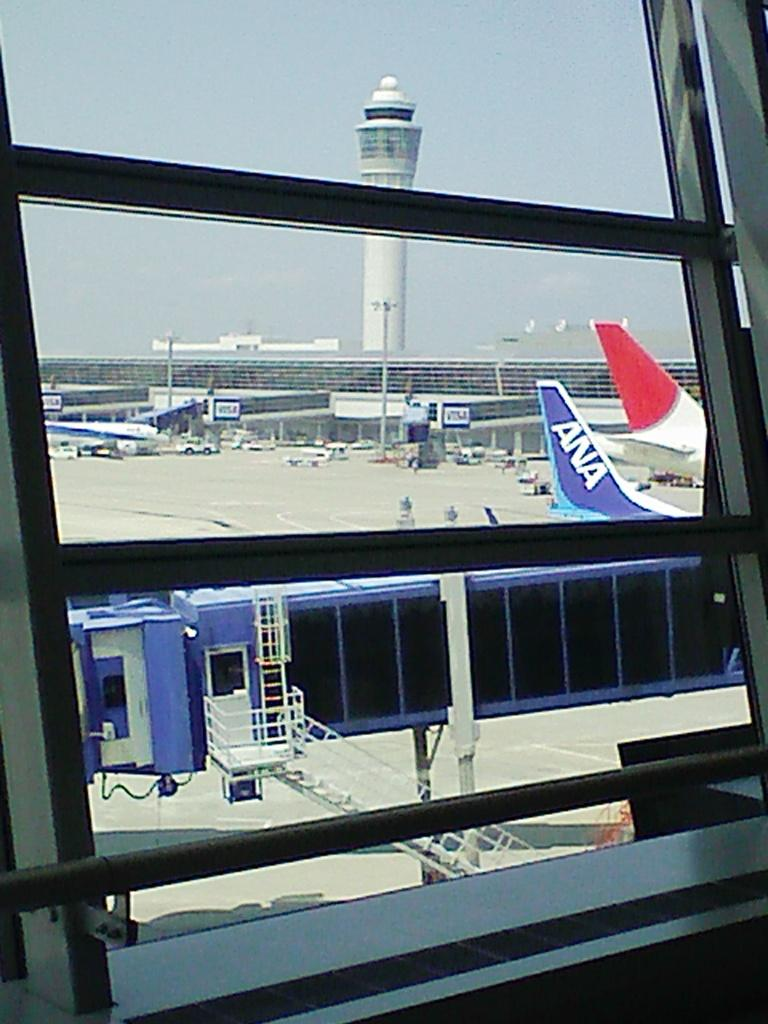What is the main subject of the image? The main subject of the image is a boarding tunnel. What can be seen in the background of the image? In the background of the image, there are airplanes, poles, and a tower. How many ants can be seen crawling on the representative's car in the image? There is no representative or car present in the image, so it is not possible to answer that question. 